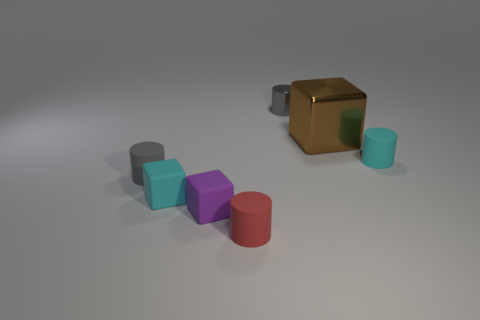There is a big object that is right of the purple rubber thing; is it the same shape as the red thing?
Offer a very short reply. No. Are there more large cubes left of the gray shiny cylinder than tiny cyan matte cubes that are on the left side of the gray matte cylinder?
Ensure brevity in your answer.  No. There is a small gray object on the right side of the tiny red object; how many tiny gray matte objects are on the right side of it?
Offer a terse response. 0. There is a object that is the same color as the shiny cylinder; what material is it?
Make the answer very short. Rubber. What number of other objects are the same color as the small metallic cylinder?
Your answer should be very brief. 1. There is a rubber thing behind the tiny gray object that is in front of the gray metal object; what color is it?
Offer a very short reply. Cyan. Are there any large rubber things that have the same color as the large cube?
Keep it short and to the point. No. How many metal things are large brown cubes or large purple blocks?
Ensure brevity in your answer.  1. Are there any tiny cyan cylinders made of the same material as the small purple block?
Give a very brief answer. Yes. What number of things are in front of the brown cube and on the right side of the tiny gray metallic cylinder?
Make the answer very short. 1. 